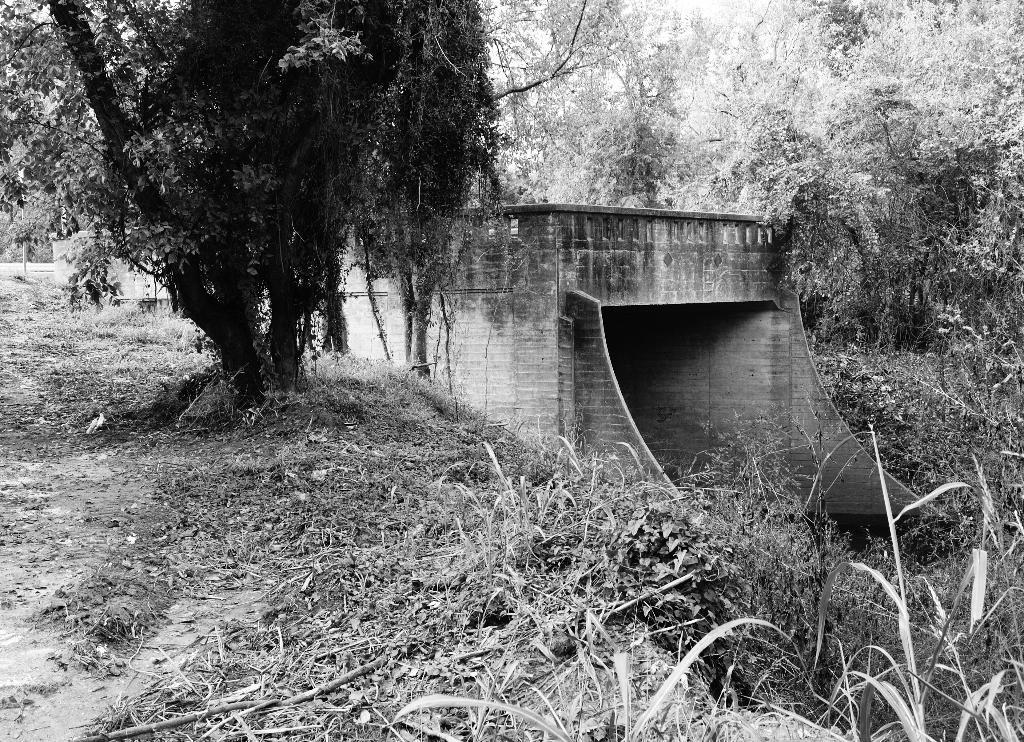Can you describe this image briefly? In this image I can see trees and grass. I can also see a bridge and a sky and the image is in black and white. 